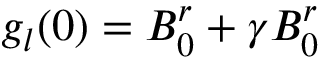Convert formula to latex. <formula><loc_0><loc_0><loc_500><loc_500>g _ { l } ( 0 ) = B _ { 0 } ^ { r } + \gamma B _ { 0 } ^ { r }</formula> 